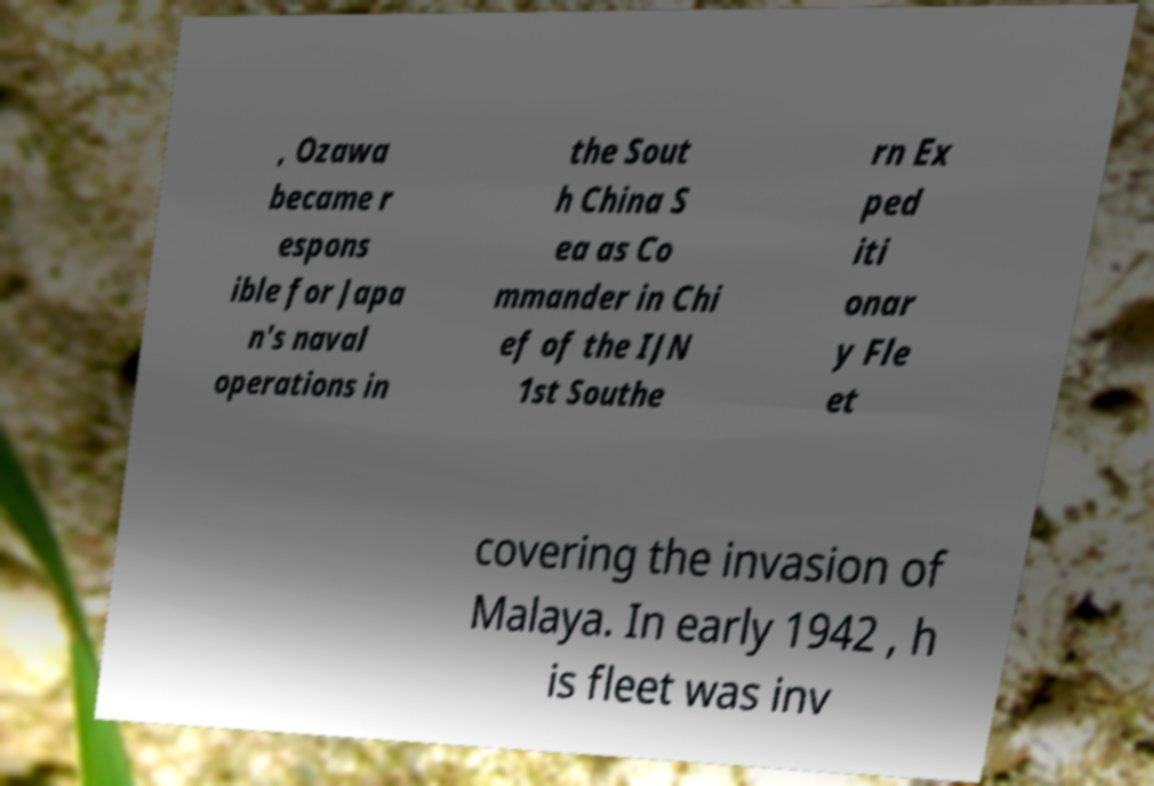Can you read and provide the text displayed in the image?This photo seems to have some interesting text. Can you extract and type it out for me? , Ozawa became r espons ible for Japa n's naval operations in the Sout h China S ea as Co mmander in Chi ef of the IJN 1st Southe rn Ex ped iti onar y Fle et covering the invasion of Malaya. In early 1942 , h is fleet was inv 